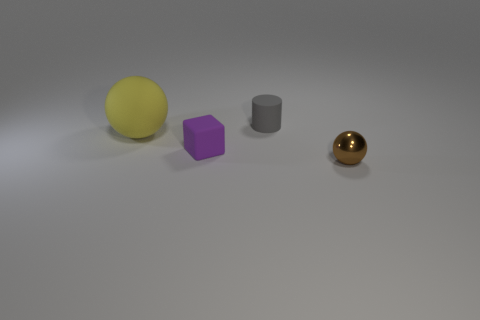Are the small purple thing and the tiny gray cylinder made of the same material?
Your response must be concise. Yes. What size is the rubber object that is behind the small purple rubber block and in front of the cylinder?
Offer a very short reply. Large. How many gray cylinders have the same size as the cube?
Your response must be concise. 1. There is a matte thing that is to the left of the small rubber object that is in front of the gray cylinder; how big is it?
Your answer should be very brief. Large. Does the purple matte object that is in front of the yellow rubber object have the same shape as the small thing that is right of the gray matte cylinder?
Your response must be concise. No. What color is the object that is both on the right side of the big yellow matte thing and left of the gray rubber thing?
Provide a short and direct response. Purple. The ball that is to the left of the tiny cylinder is what color?
Your answer should be very brief. Yellow. Is there a sphere right of the sphere behind the tiny brown object?
Your answer should be very brief. Yes. There is a metallic ball; is it the same color as the small rubber thing in front of the gray matte cylinder?
Give a very brief answer. No. Are there any other small things that have the same material as the gray thing?
Make the answer very short. Yes. 